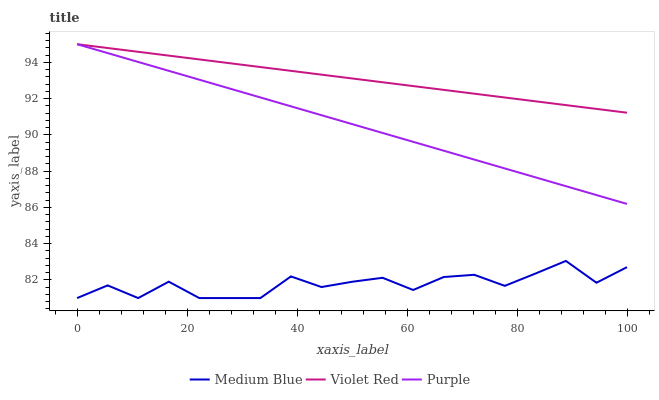Does Medium Blue have the minimum area under the curve?
Answer yes or no. Yes. Does Violet Red have the maximum area under the curve?
Answer yes or no. Yes. Does Violet Red have the minimum area under the curve?
Answer yes or no. No. Does Medium Blue have the maximum area under the curve?
Answer yes or no. No. Is Violet Red the smoothest?
Answer yes or no. Yes. Is Medium Blue the roughest?
Answer yes or no. Yes. Is Medium Blue the smoothest?
Answer yes or no. No. Is Violet Red the roughest?
Answer yes or no. No. Does Violet Red have the lowest value?
Answer yes or no. No. Does Violet Red have the highest value?
Answer yes or no. Yes. Does Medium Blue have the highest value?
Answer yes or no. No. Is Medium Blue less than Violet Red?
Answer yes or no. Yes. Is Purple greater than Medium Blue?
Answer yes or no. Yes. Does Violet Red intersect Purple?
Answer yes or no. Yes. Is Violet Red less than Purple?
Answer yes or no. No. Is Violet Red greater than Purple?
Answer yes or no. No. Does Medium Blue intersect Violet Red?
Answer yes or no. No. 